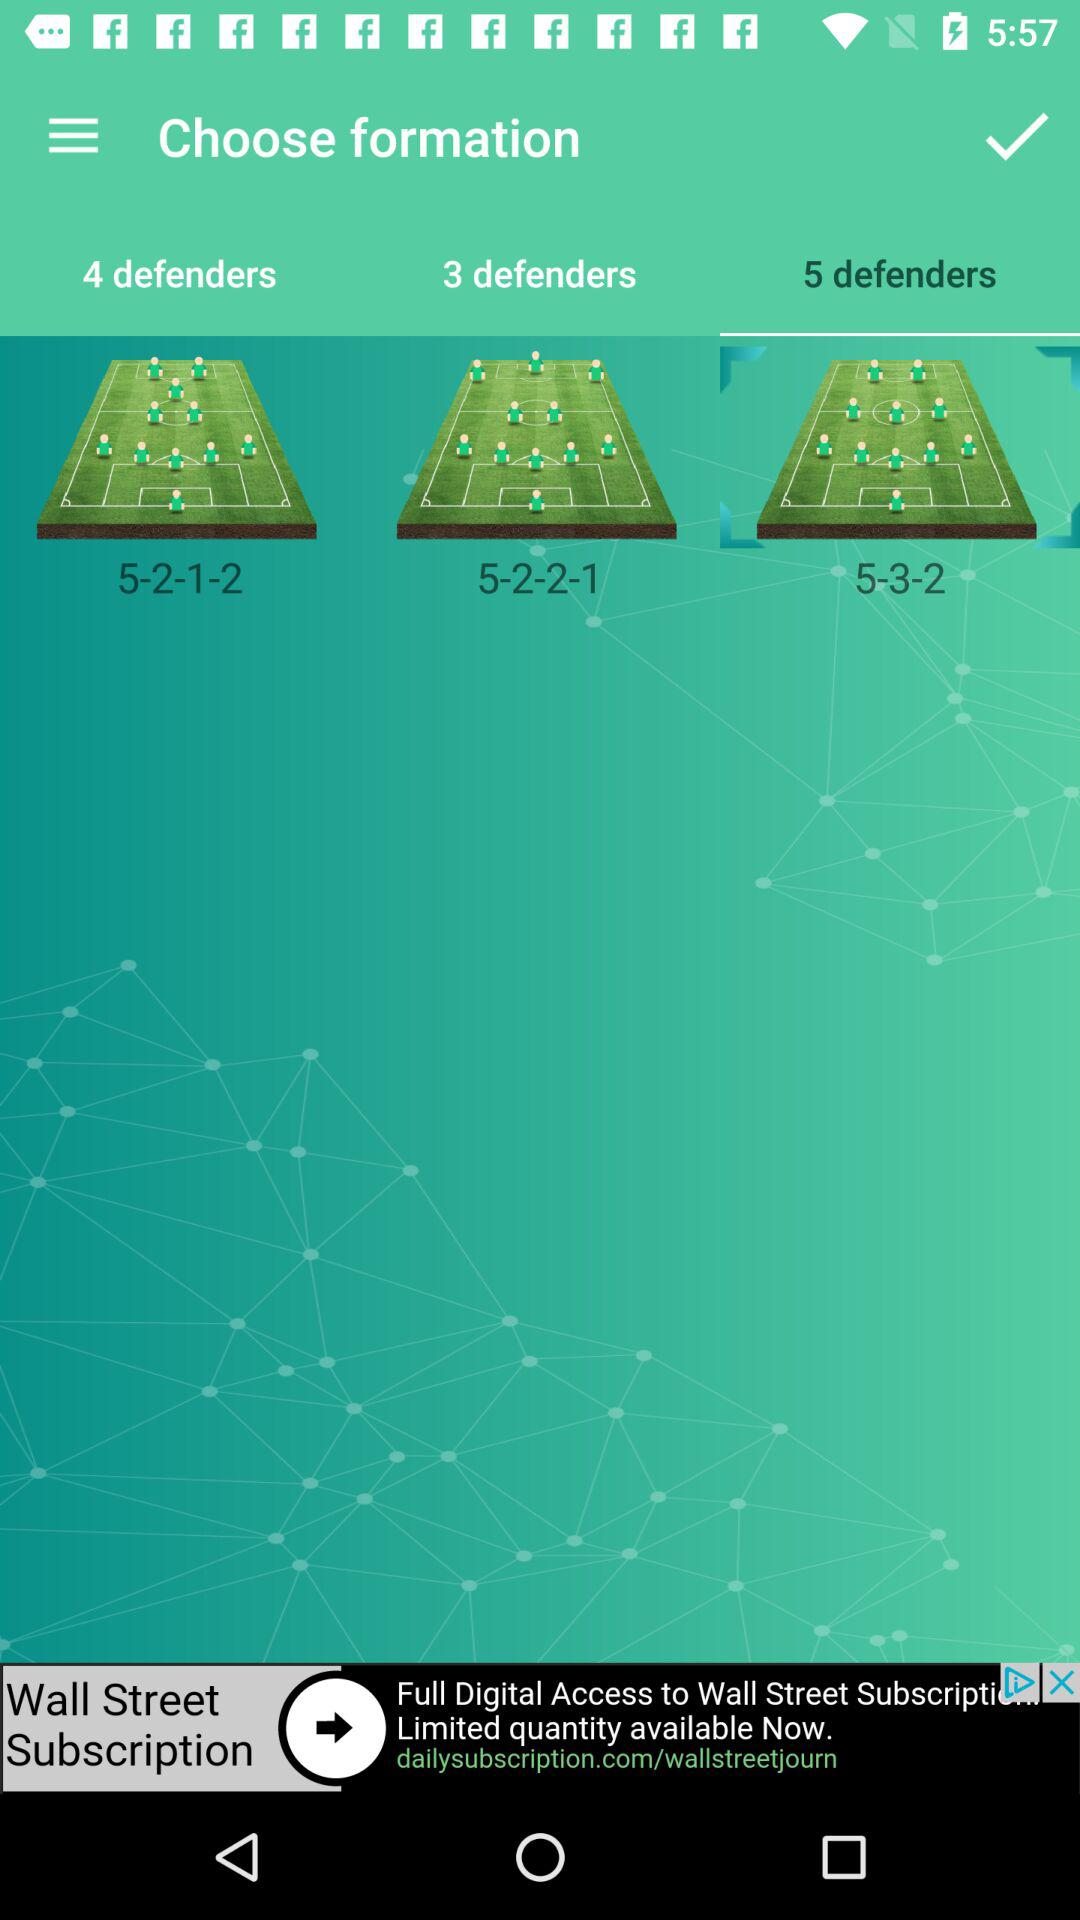How many more defenders are in the 5-3-2 formation than the 5-2-1- formation?
Answer the question using a single word or phrase. 1 